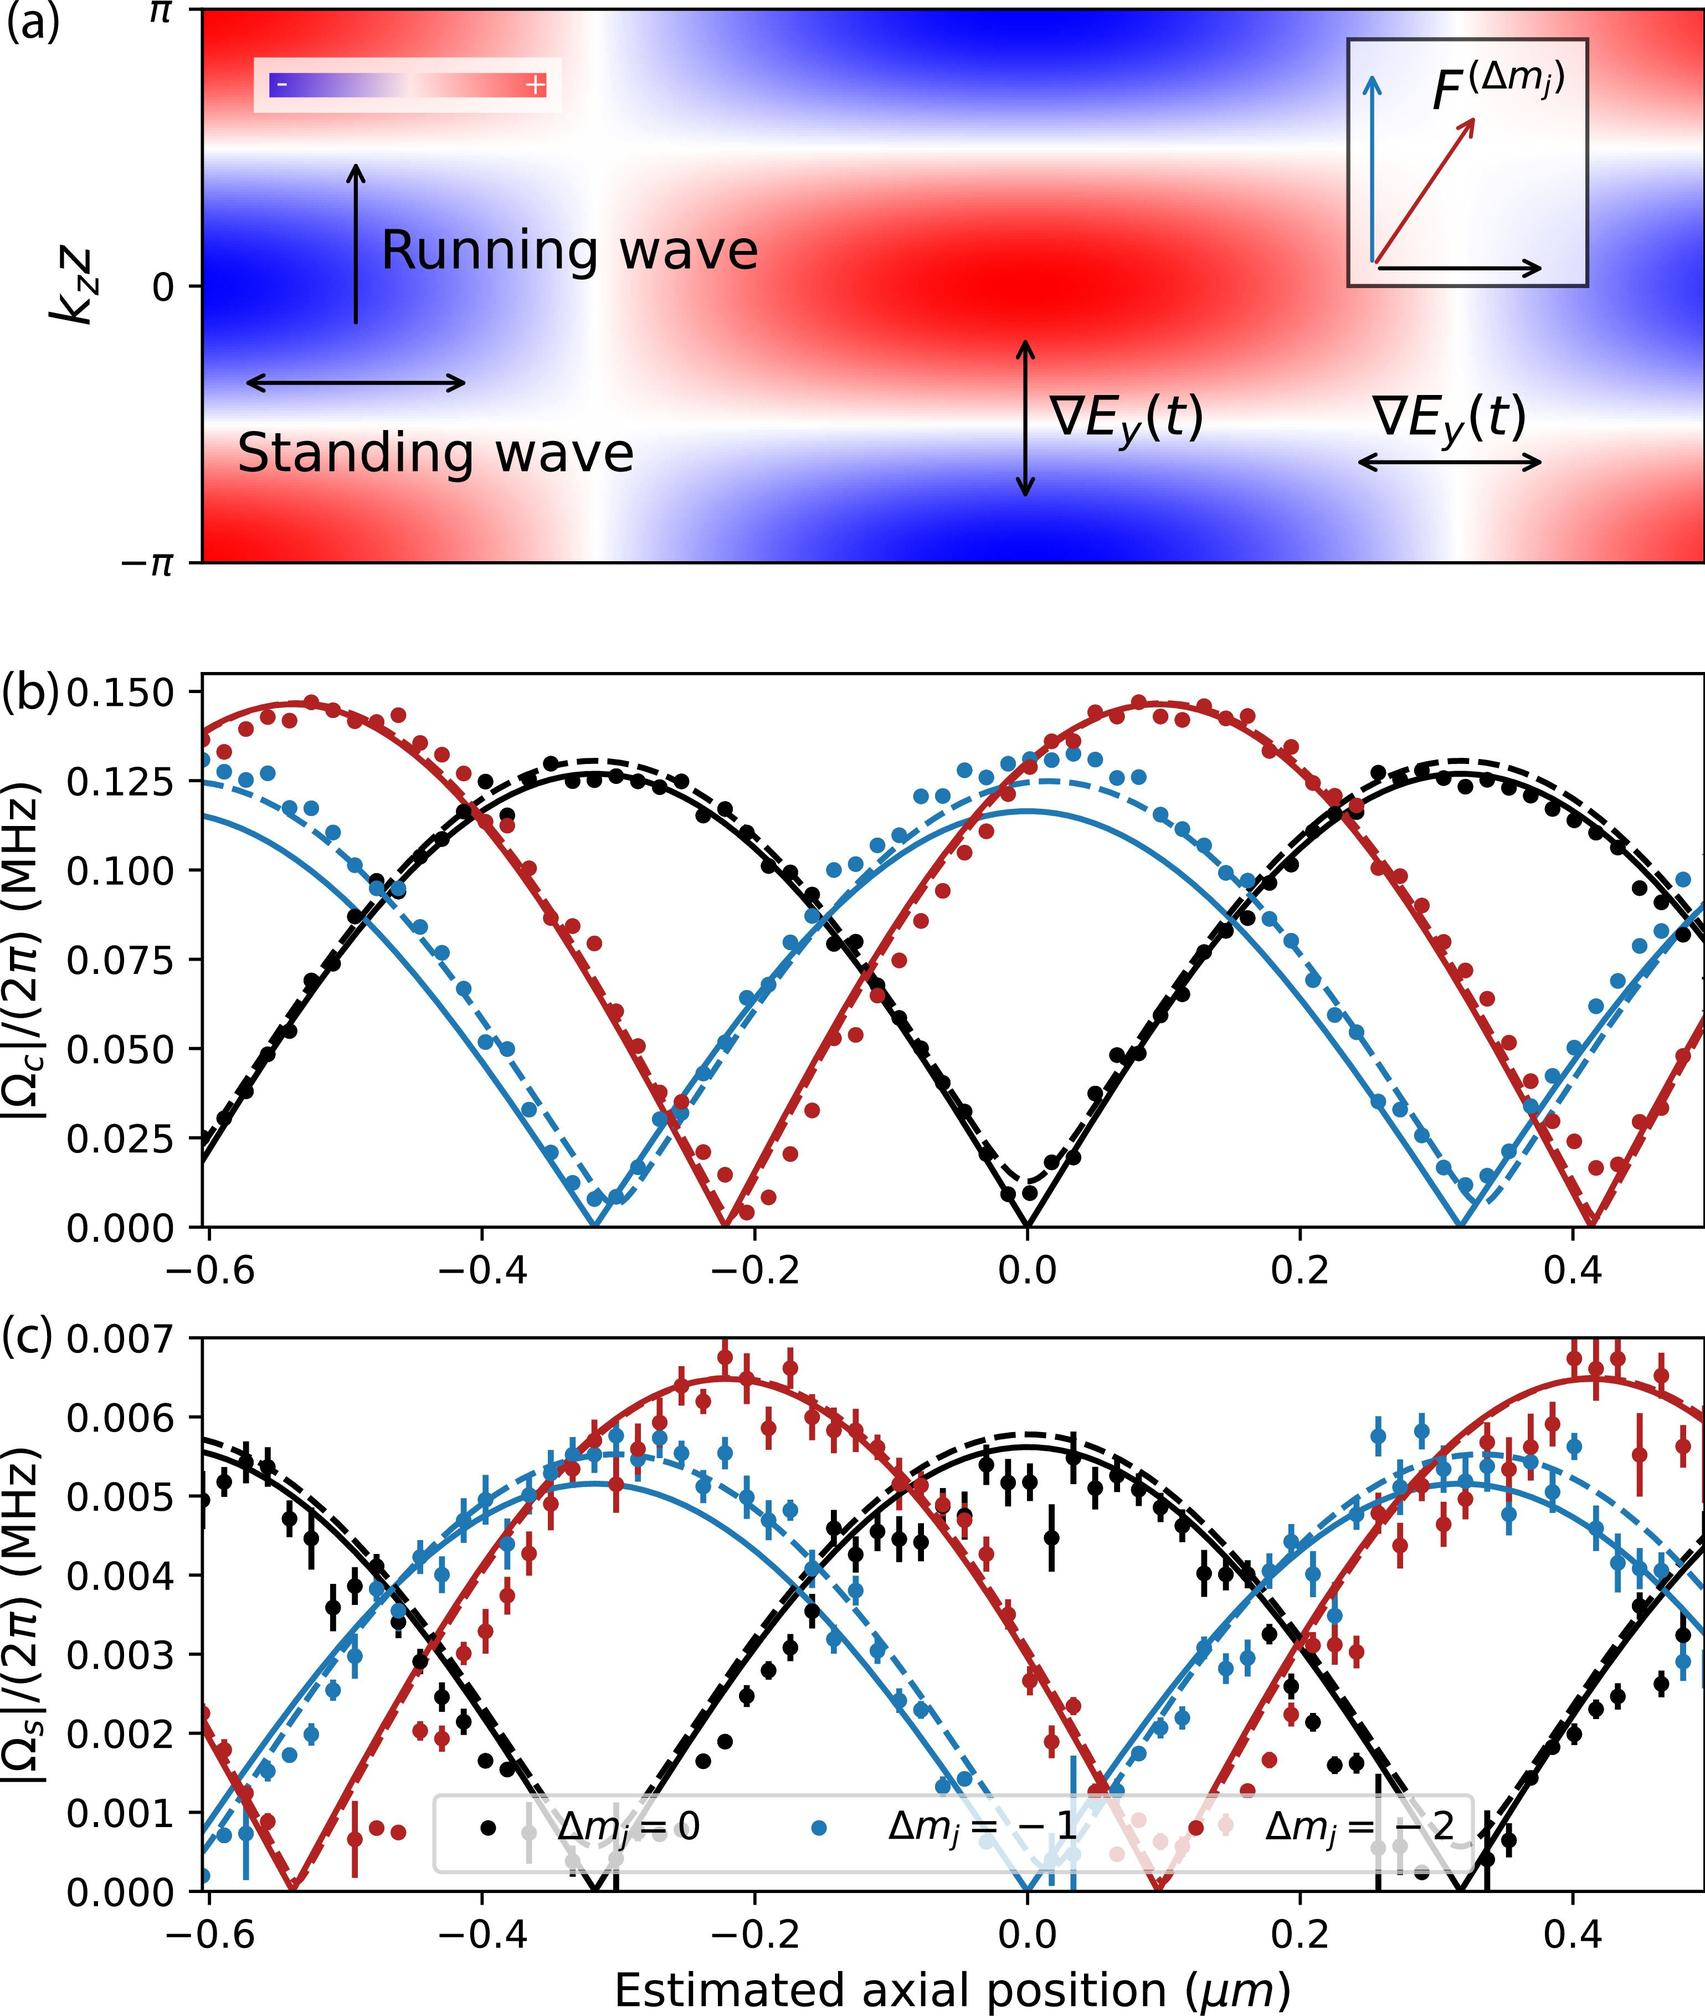How does the variation in \( \Omega_S \) shown in Figure (c) relate to the positioning of the waves denoted in Figure (a)? The variation in \( \Omega_S \) corresponds to changes in the axial positioning of the ions or particles as depicted in Figure (c), which could be influenced by the interactions between standing and running wave patterns shown in Figure (a). When these patterns overlap or intersect, they can significantly affect the particles' motion and stability, as indicated by the changes in \( \Omega_S \). 